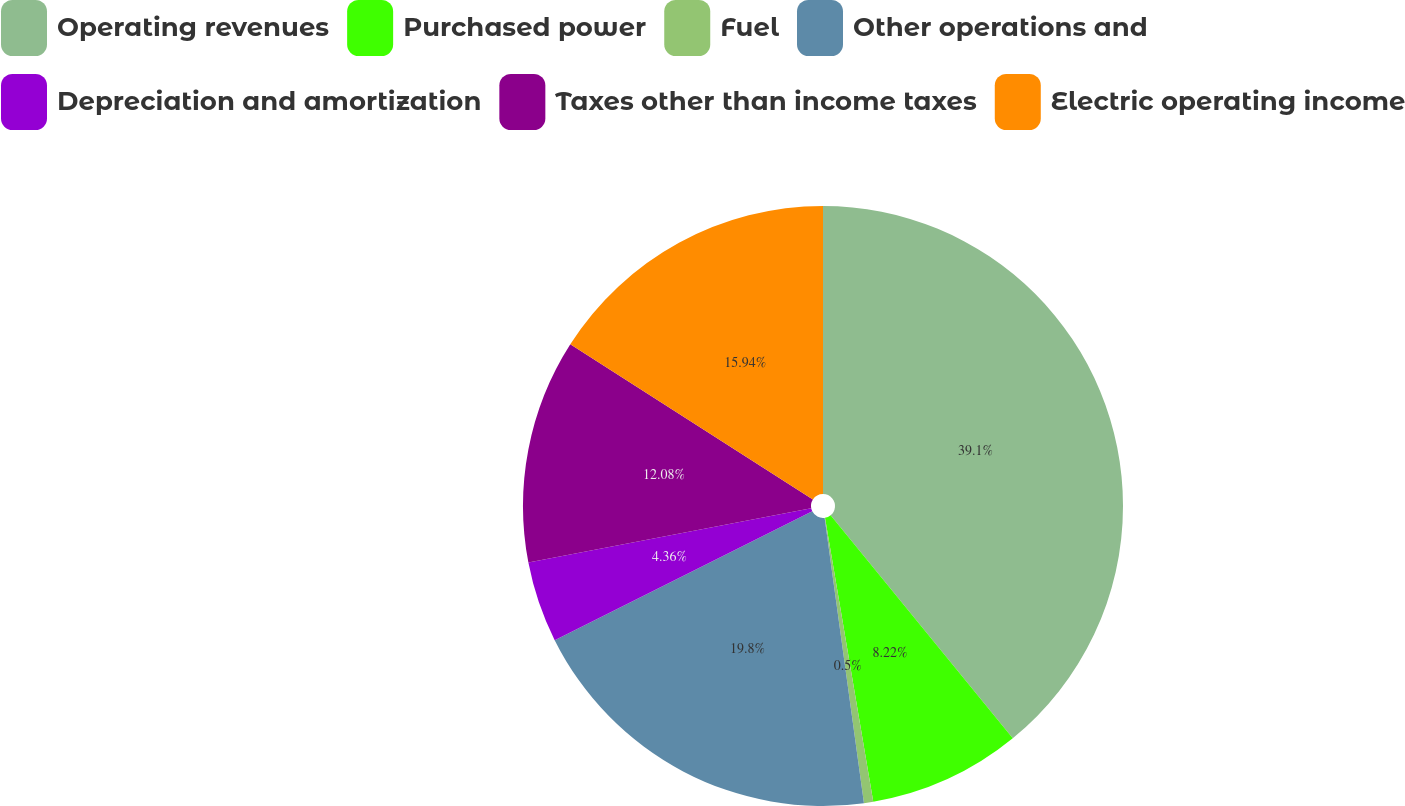Convert chart to OTSL. <chart><loc_0><loc_0><loc_500><loc_500><pie_chart><fcel>Operating revenues<fcel>Purchased power<fcel>Fuel<fcel>Other operations and<fcel>Depreciation and amortization<fcel>Taxes other than income taxes<fcel>Electric operating income<nl><fcel>39.1%<fcel>8.22%<fcel>0.5%<fcel>19.8%<fcel>4.36%<fcel>12.08%<fcel>15.94%<nl></chart> 